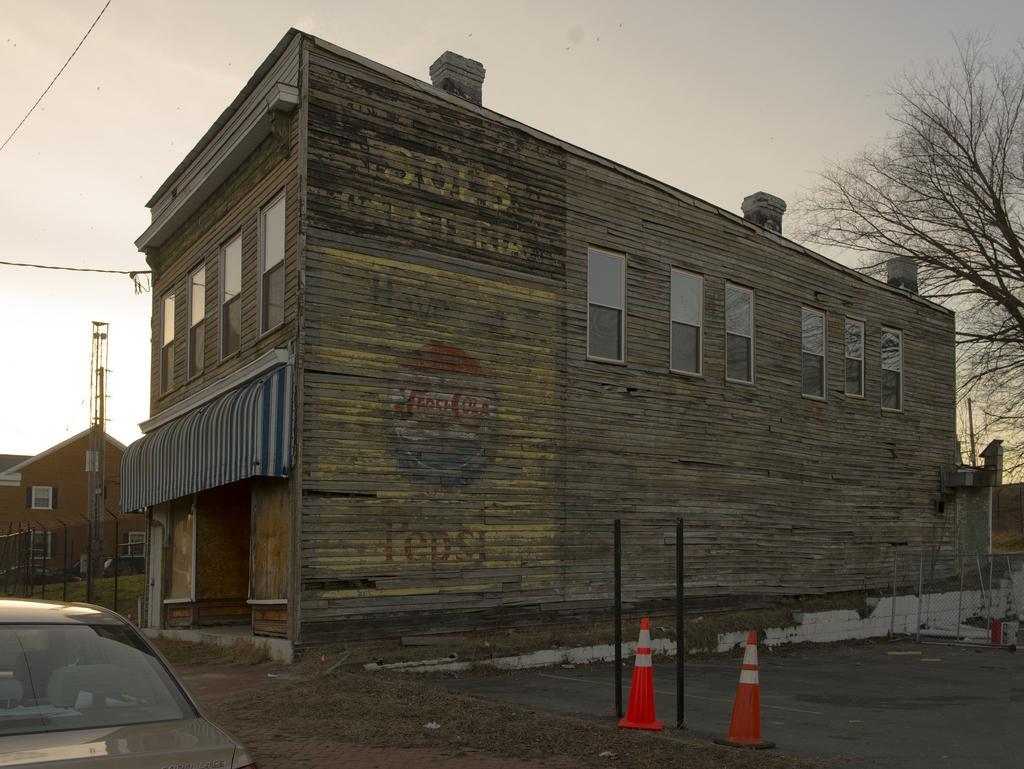How would you summarize this image in a sentence or two? In this picture we can see the buildings. At the bottom there are two traffic cones near to the pole. On the right we can see the trees. In the bottom left corner there is a car, beside that we can see fencing and grass. In front of the red color building there is a tower. On the left we can see the electric wires. At the top we can see sky, clouds and birds. 